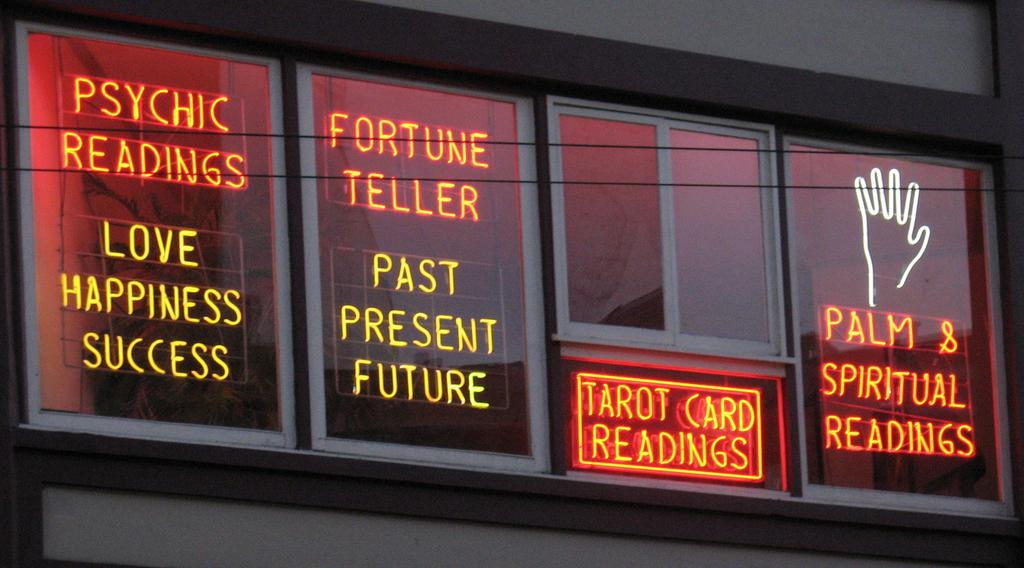<image>
Create a compact narrative representing the image presented. A palm reader with a neon sign that says everything they offer. 